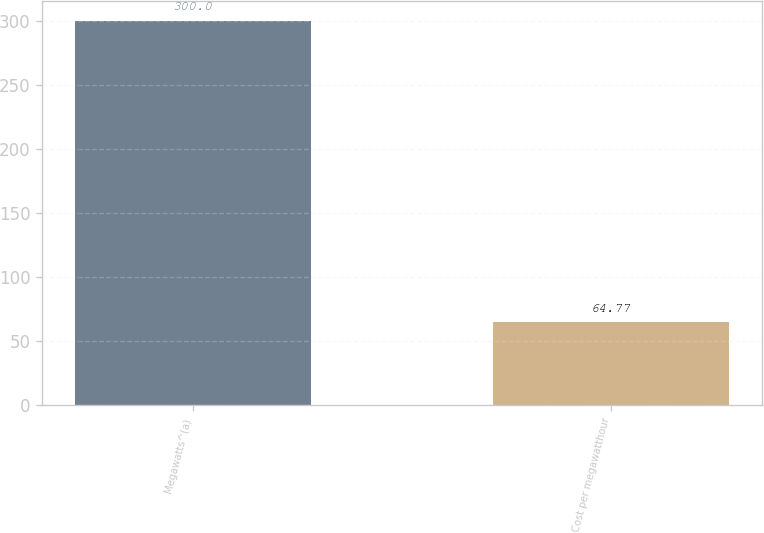Convert chart to OTSL. <chart><loc_0><loc_0><loc_500><loc_500><bar_chart><fcel>Megawatts^(a)<fcel>Cost per megawatthour<nl><fcel>300<fcel>64.77<nl></chart> 